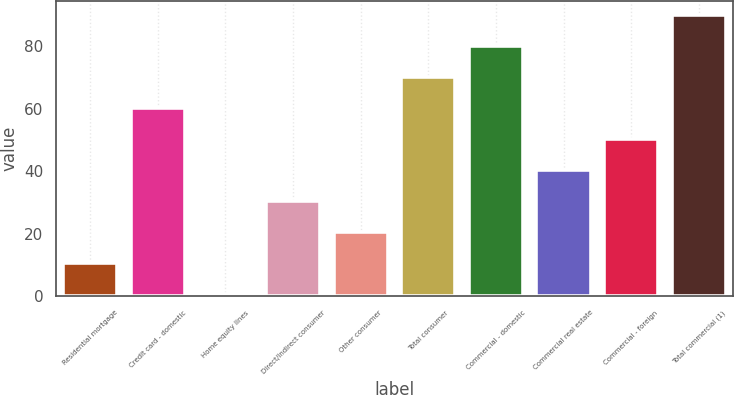<chart> <loc_0><loc_0><loc_500><loc_500><bar_chart><fcel>Residential mortgage<fcel>Credit card - domestic<fcel>Home equity lines<fcel>Direct/Indirect consumer<fcel>Other consumer<fcel>Total consumer<fcel>Commercial - domestic<fcel>Commercial real estate<fcel>Commercial - foreign<fcel>Total commercial (1)<nl><fcel>10.72<fcel>60.32<fcel>0.8<fcel>30.56<fcel>20.64<fcel>70.24<fcel>80.16<fcel>40.48<fcel>50.4<fcel>90.08<nl></chart> 